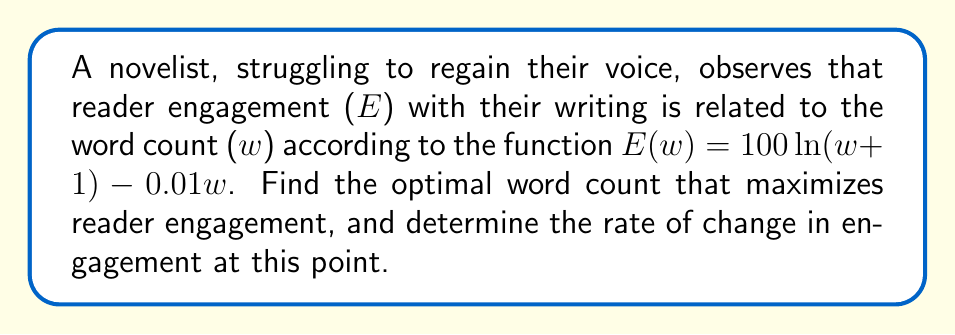Can you solve this math problem? 1) To find the optimal word count, we need to find the maximum of the function $E(w)$. This occurs where the derivative $E'(w) = 0$.

2) Let's find the derivative of $E(w)$:
   $$E'(w) = \frac{d}{dw}[100\ln(w+1) - 0.01w]$$
   $$E'(w) = \frac{100}{w+1} - 0.01$$

3) Set $E'(w) = 0$ and solve for $w$:
   $$\frac{100}{w+1} - 0.01 = 0$$
   $$\frac{100}{w+1} = 0.01$$
   $$100 = 0.01(w+1)$$
   $$10000 = w+1$$
   $$w = 9999$$

4) The second derivative $E''(w) = -\frac{100}{(w+1)^2} < 0$ for all $w$, confirming this is a maximum.

5) To find the rate of change at this point, we evaluate $E'(9999)$:
   $$E'(9999) = \frac{100}{9999+1} - 0.01 = 0.01 - 0.01 = 0$$

This confirms that the rate of change at the optimal word count is zero, as expected at a maximum.
Answer: Optimal word count: 9999 words. Rate of change at this point: 0. 